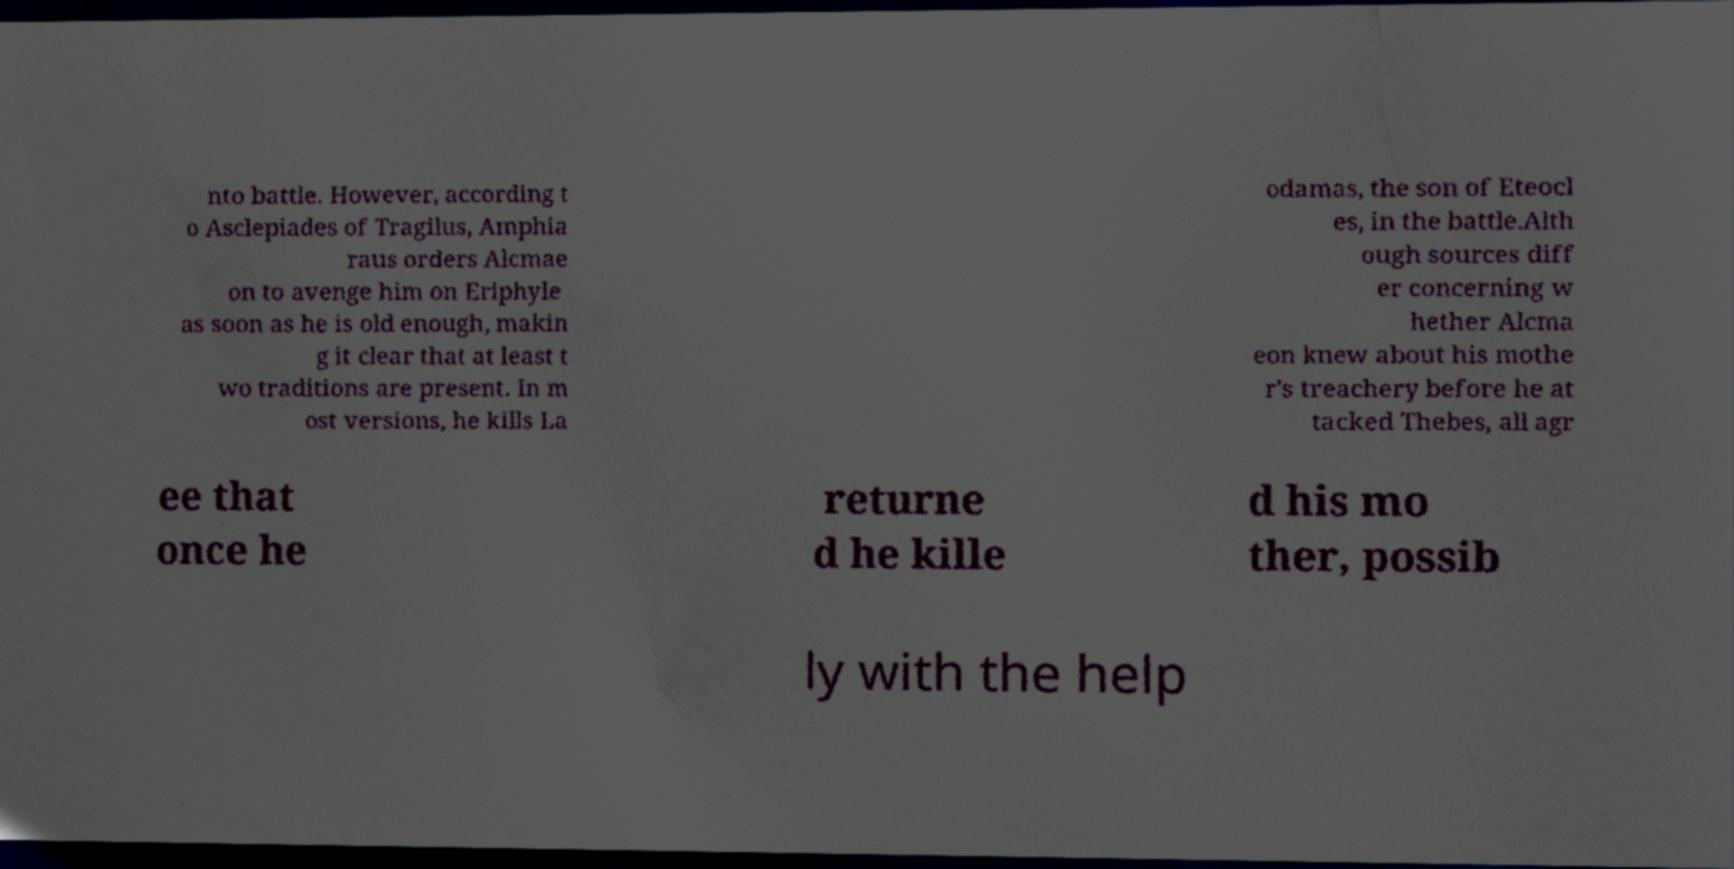Can you accurately transcribe the text from the provided image for me? nto battle. However, according t o Asclepiades of Tragilus, Amphia raus orders Alcmae on to avenge him on Eriphyle as soon as he is old enough, makin g it clear that at least t wo traditions are present. In m ost versions, he kills La odamas, the son of Eteocl es, in the battle.Alth ough sources diff er concerning w hether Alcma eon knew about his mothe r's treachery before he at tacked Thebes, all agr ee that once he returne d he kille d his mo ther, possib ly with the help 